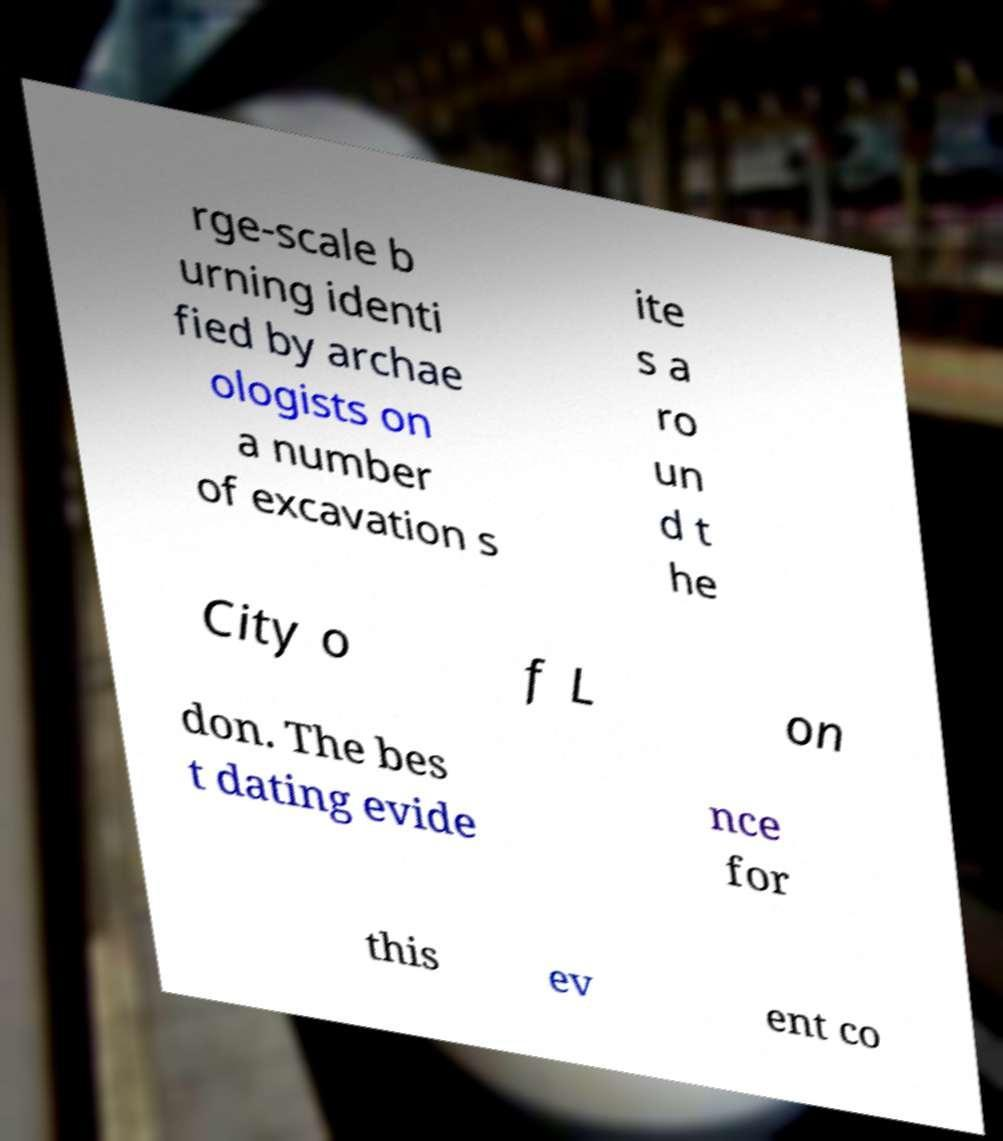Please read and relay the text visible in this image. What does it say? rge-scale b urning identi fied by archae ologists on a number of excavation s ite s a ro un d t he City o f L on don. The bes t dating evide nce for this ev ent co 